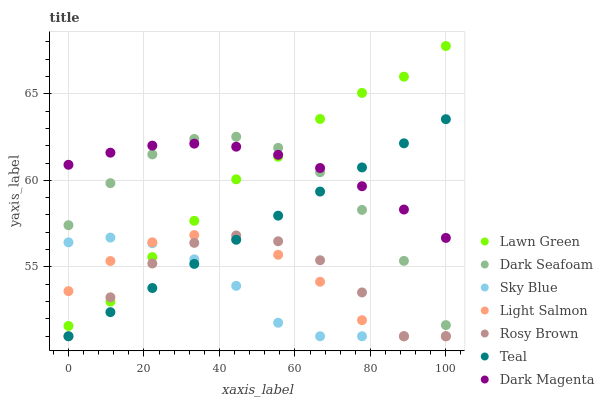Does Sky Blue have the minimum area under the curve?
Answer yes or no. Yes. Does Dark Magenta have the maximum area under the curve?
Answer yes or no. Yes. Does Light Salmon have the minimum area under the curve?
Answer yes or no. No. Does Light Salmon have the maximum area under the curve?
Answer yes or no. No. Is Teal the smoothest?
Answer yes or no. Yes. Is Rosy Brown the roughest?
Answer yes or no. Yes. Is Light Salmon the smoothest?
Answer yes or no. No. Is Light Salmon the roughest?
Answer yes or no. No. Does Light Salmon have the lowest value?
Answer yes or no. Yes. Does Dark Magenta have the lowest value?
Answer yes or no. No. Does Lawn Green have the highest value?
Answer yes or no. Yes. Does Light Salmon have the highest value?
Answer yes or no. No. Is Light Salmon less than Dark Magenta?
Answer yes or no. Yes. Is Dark Magenta greater than Sky Blue?
Answer yes or no. Yes. Does Sky Blue intersect Lawn Green?
Answer yes or no. Yes. Is Sky Blue less than Lawn Green?
Answer yes or no. No. Is Sky Blue greater than Lawn Green?
Answer yes or no. No. Does Light Salmon intersect Dark Magenta?
Answer yes or no. No. 